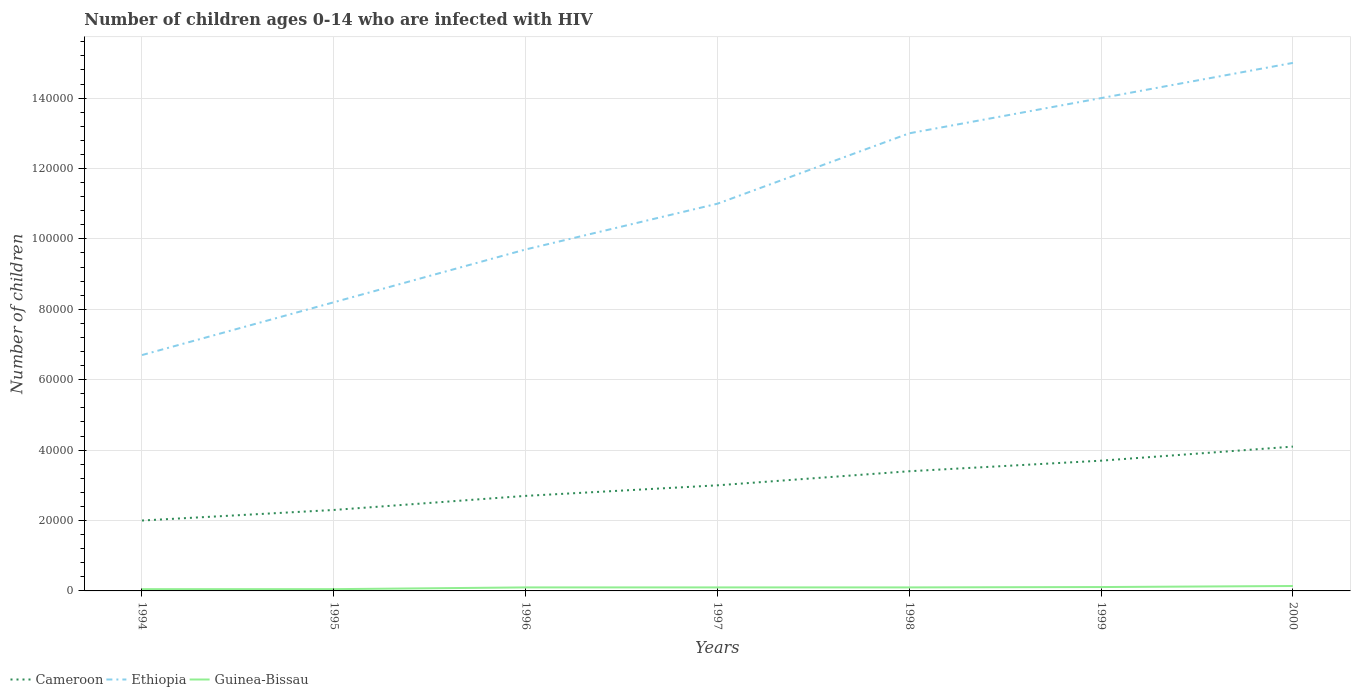Across all years, what is the maximum number of HIV infected children in Ethiopia?
Your response must be concise. 6.70e+04. In which year was the number of HIV infected children in Cameroon maximum?
Offer a very short reply. 1994. What is the total number of HIV infected children in Cameroon in the graph?
Keep it short and to the point. -3000. What is the difference between the highest and the second highest number of HIV infected children in Guinea-Bissau?
Keep it short and to the point. 900. What is the difference between the highest and the lowest number of HIV infected children in Cameroon?
Provide a succinct answer. 3. How many years are there in the graph?
Your answer should be compact. 7. Does the graph contain any zero values?
Your answer should be compact. No. Where does the legend appear in the graph?
Ensure brevity in your answer.  Bottom left. How many legend labels are there?
Your answer should be very brief. 3. What is the title of the graph?
Your answer should be compact. Number of children ages 0-14 who are infected with HIV. What is the label or title of the X-axis?
Keep it short and to the point. Years. What is the label or title of the Y-axis?
Your answer should be compact. Number of children. What is the Number of children in Ethiopia in 1994?
Offer a terse response. 6.70e+04. What is the Number of children in Cameroon in 1995?
Offer a terse response. 2.30e+04. What is the Number of children in Ethiopia in 1995?
Offer a very short reply. 8.20e+04. What is the Number of children of Guinea-Bissau in 1995?
Make the answer very short. 500. What is the Number of children in Cameroon in 1996?
Give a very brief answer. 2.70e+04. What is the Number of children in Ethiopia in 1996?
Ensure brevity in your answer.  9.70e+04. What is the Number of children of Ethiopia in 1997?
Provide a succinct answer. 1.10e+05. What is the Number of children of Guinea-Bissau in 1997?
Your answer should be compact. 1000. What is the Number of children of Cameroon in 1998?
Offer a very short reply. 3.40e+04. What is the Number of children of Cameroon in 1999?
Your answer should be very brief. 3.70e+04. What is the Number of children of Ethiopia in 1999?
Provide a short and direct response. 1.40e+05. What is the Number of children in Guinea-Bissau in 1999?
Offer a terse response. 1100. What is the Number of children of Cameroon in 2000?
Give a very brief answer. 4.10e+04. What is the Number of children of Ethiopia in 2000?
Keep it short and to the point. 1.50e+05. What is the Number of children in Guinea-Bissau in 2000?
Offer a very short reply. 1400. Across all years, what is the maximum Number of children of Cameroon?
Offer a terse response. 4.10e+04. Across all years, what is the maximum Number of children of Ethiopia?
Give a very brief answer. 1.50e+05. Across all years, what is the maximum Number of children in Guinea-Bissau?
Ensure brevity in your answer.  1400. Across all years, what is the minimum Number of children in Ethiopia?
Offer a terse response. 6.70e+04. What is the total Number of children in Cameroon in the graph?
Offer a very short reply. 2.12e+05. What is the total Number of children of Ethiopia in the graph?
Provide a succinct answer. 7.76e+05. What is the total Number of children of Guinea-Bissau in the graph?
Your response must be concise. 6500. What is the difference between the Number of children in Cameroon in 1994 and that in 1995?
Ensure brevity in your answer.  -3000. What is the difference between the Number of children of Ethiopia in 1994 and that in 1995?
Ensure brevity in your answer.  -1.50e+04. What is the difference between the Number of children in Guinea-Bissau in 1994 and that in 1995?
Ensure brevity in your answer.  0. What is the difference between the Number of children of Cameroon in 1994 and that in 1996?
Provide a short and direct response. -7000. What is the difference between the Number of children in Ethiopia in 1994 and that in 1996?
Keep it short and to the point. -3.00e+04. What is the difference between the Number of children in Guinea-Bissau in 1994 and that in 1996?
Keep it short and to the point. -500. What is the difference between the Number of children in Cameroon in 1994 and that in 1997?
Give a very brief answer. -10000. What is the difference between the Number of children of Ethiopia in 1994 and that in 1997?
Ensure brevity in your answer.  -4.30e+04. What is the difference between the Number of children in Guinea-Bissau in 1994 and that in 1997?
Ensure brevity in your answer.  -500. What is the difference between the Number of children in Cameroon in 1994 and that in 1998?
Keep it short and to the point. -1.40e+04. What is the difference between the Number of children of Ethiopia in 1994 and that in 1998?
Offer a terse response. -6.30e+04. What is the difference between the Number of children in Guinea-Bissau in 1994 and that in 1998?
Provide a short and direct response. -500. What is the difference between the Number of children in Cameroon in 1994 and that in 1999?
Give a very brief answer. -1.70e+04. What is the difference between the Number of children of Ethiopia in 1994 and that in 1999?
Offer a very short reply. -7.30e+04. What is the difference between the Number of children of Guinea-Bissau in 1994 and that in 1999?
Offer a terse response. -600. What is the difference between the Number of children in Cameroon in 1994 and that in 2000?
Provide a short and direct response. -2.10e+04. What is the difference between the Number of children in Ethiopia in 1994 and that in 2000?
Offer a very short reply. -8.30e+04. What is the difference between the Number of children in Guinea-Bissau in 1994 and that in 2000?
Offer a terse response. -900. What is the difference between the Number of children in Cameroon in 1995 and that in 1996?
Provide a short and direct response. -4000. What is the difference between the Number of children in Ethiopia in 1995 and that in 1996?
Give a very brief answer. -1.50e+04. What is the difference between the Number of children of Guinea-Bissau in 1995 and that in 1996?
Offer a terse response. -500. What is the difference between the Number of children of Cameroon in 1995 and that in 1997?
Provide a succinct answer. -7000. What is the difference between the Number of children in Ethiopia in 1995 and that in 1997?
Offer a very short reply. -2.80e+04. What is the difference between the Number of children in Guinea-Bissau in 1995 and that in 1997?
Offer a very short reply. -500. What is the difference between the Number of children in Cameroon in 1995 and that in 1998?
Offer a terse response. -1.10e+04. What is the difference between the Number of children of Ethiopia in 1995 and that in 1998?
Keep it short and to the point. -4.80e+04. What is the difference between the Number of children of Guinea-Bissau in 1995 and that in 1998?
Offer a terse response. -500. What is the difference between the Number of children of Cameroon in 1995 and that in 1999?
Provide a succinct answer. -1.40e+04. What is the difference between the Number of children in Ethiopia in 1995 and that in 1999?
Ensure brevity in your answer.  -5.80e+04. What is the difference between the Number of children of Guinea-Bissau in 1995 and that in 1999?
Keep it short and to the point. -600. What is the difference between the Number of children of Cameroon in 1995 and that in 2000?
Offer a terse response. -1.80e+04. What is the difference between the Number of children of Ethiopia in 1995 and that in 2000?
Keep it short and to the point. -6.80e+04. What is the difference between the Number of children in Guinea-Bissau in 1995 and that in 2000?
Offer a terse response. -900. What is the difference between the Number of children in Cameroon in 1996 and that in 1997?
Offer a very short reply. -3000. What is the difference between the Number of children in Ethiopia in 1996 and that in 1997?
Keep it short and to the point. -1.30e+04. What is the difference between the Number of children in Guinea-Bissau in 1996 and that in 1997?
Give a very brief answer. 0. What is the difference between the Number of children of Cameroon in 1996 and that in 1998?
Ensure brevity in your answer.  -7000. What is the difference between the Number of children in Ethiopia in 1996 and that in 1998?
Your answer should be very brief. -3.30e+04. What is the difference between the Number of children in Guinea-Bissau in 1996 and that in 1998?
Offer a very short reply. 0. What is the difference between the Number of children in Cameroon in 1996 and that in 1999?
Provide a succinct answer. -10000. What is the difference between the Number of children of Ethiopia in 1996 and that in 1999?
Your answer should be very brief. -4.30e+04. What is the difference between the Number of children of Guinea-Bissau in 1996 and that in 1999?
Provide a succinct answer. -100. What is the difference between the Number of children of Cameroon in 1996 and that in 2000?
Provide a short and direct response. -1.40e+04. What is the difference between the Number of children of Ethiopia in 1996 and that in 2000?
Ensure brevity in your answer.  -5.30e+04. What is the difference between the Number of children in Guinea-Bissau in 1996 and that in 2000?
Your response must be concise. -400. What is the difference between the Number of children in Cameroon in 1997 and that in 1998?
Keep it short and to the point. -4000. What is the difference between the Number of children in Ethiopia in 1997 and that in 1998?
Your response must be concise. -2.00e+04. What is the difference between the Number of children in Cameroon in 1997 and that in 1999?
Ensure brevity in your answer.  -7000. What is the difference between the Number of children in Ethiopia in 1997 and that in 1999?
Your answer should be compact. -3.00e+04. What is the difference between the Number of children in Guinea-Bissau in 1997 and that in 1999?
Provide a succinct answer. -100. What is the difference between the Number of children in Cameroon in 1997 and that in 2000?
Make the answer very short. -1.10e+04. What is the difference between the Number of children of Guinea-Bissau in 1997 and that in 2000?
Offer a terse response. -400. What is the difference between the Number of children in Cameroon in 1998 and that in 1999?
Make the answer very short. -3000. What is the difference between the Number of children of Ethiopia in 1998 and that in 1999?
Your answer should be very brief. -10000. What is the difference between the Number of children of Guinea-Bissau in 1998 and that in 1999?
Your answer should be very brief. -100. What is the difference between the Number of children in Cameroon in 1998 and that in 2000?
Offer a very short reply. -7000. What is the difference between the Number of children in Ethiopia in 1998 and that in 2000?
Keep it short and to the point. -2.00e+04. What is the difference between the Number of children in Guinea-Bissau in 1998 and that in 2000?
Your response must be concise. -400. What is the difference between the Number of children of Cameroon in 1999 and that in 2000?
Your answer should be compact. -4000. What is the difference between the Number of children in Ethiopia in 1999 and that in 2000?
Offer a terse response. -10000. What is the difference between the Number of children in Guinea-Bissau in 1999 and that in 2000?
Your answer should be compact. -300. What is the difference between the Number of children in Cameroon in 1994 and the Number of children in Ethiopia in 1995?
Give a very brief answer. -6.20e+04. What is the difference between the Number of children in Cameroon in 1994 and the Number of children in Guinea-Bissau in 1995?
Give a very brief answer. 1.95e+04. What is the difference between the Number of children of Ethiopia in 1994 and the Number of children of Guinea-Bissau in 1995?
Your response must be concise. 6.65e+04. What is the difference between the Number of children in Cameroon in 1994 and the Number of children in Ethiopia in 1996?
Make the answer very short. -7.70e+04. What is the difference between the Number of children of Cameroon in 1994 and the Number of children of Guinea-Bissau in 1996?
Your answer should be very brief. 1.90e+04. What is the difference between the Number of children in Ethiopia in 1994 and the Number of children in Guinea-Bissau in 1996?
Your answer should be very brief. 6.60e+04. What is the difference between the Number of children of Cameroon in 1994 and the Number of children of Ethiopia in 1997?
Provide a short and direct response. -9.00e+04. What is the difference between the Number of children in Cameroon in 1994 and the Number of children in Guinea-Bissau in 1997?
Offer a very short reply. 1.90e+04. What is the difference between the Number of children of Ethiopia in 1994 and the Number of children of Guinea-Bissau in 1997?
Give a very brief answer. 6.60e+04. What is the difference between the Number of children of Cameroon in 1994 and the Number of children of Guinea-Bissau in 1998?
Your answer should be compact. 1.90e+04. What is the difference between the Number of children in Ethiopia in 1994 and the Number of children in Guinea-Bissau in 1998?
Your answer should be very brief. 6.60e+04. What is the difference between the Number of children of Cameroon in 1994 and the Number of children of Guinea-Bissau in 1999?
Your answer should be compact. 1.89e+04. What is the difference between the Number of children in Ethiopia in 1994 and the Number of children in Guinea-Bissau in 1999?
Give a very brief answer. 6.59e+04. What is the difference between the Number of children of Cameroon in 1994 and the Number of children of Guinea-Bissau in 2000?
Ensure brevity in your answer.  1.86e+04. What is the difference between the Number of children of Ethiopia in 1994 and the Number of children of Guinea-Bissau in 2000?
Provide a succinct answer. 6.56e+04. What is the difference between the Number of children in Cameroon in 1995 and the Number of children in Ethiopia in 1996?
Offer a very short reply. -7.40e+04. What is the difference between the Number of children of Cameroon in 1995 and the Number of children of Guinea-Bissau in 1996?
Offer a terse response. 2.20e+04. What is the difference between the Number of children of Ethiopia in 1995 and the Number of children of Guinea-Bissau in 1996?
Keep it short and to the point. 8.10e+04. What is the difference between the Number of children in Cameroon in 1995 and the Number of children in Ethiopia in 1997?
Ensure brevity in your answer.  -8.70e+04. What is the difference between the Number of children in Cameroon in 1995 and the Number of children in Guinea-Bissau in 1997?
Provide a succinct answer. 2.20e+04. What is the difference between the Number of children of Ethiopia in 1995 and the Number of children of Guinea-Bissau in 1997?
Give a very brief answer. 8.10e+04. What is the difference between the Number of children of Cameroon in 1995 and the Number of children of Ethiopia in 1998?
Keep it short and to the point. -1.07e+05. What is the difference between the Number of children of Cameroon in 1995 and the Number of children of Guinea-Bissau in 1998?
Provide a short and direct response. 2.20e+04. What is the difference between the Number of children in Ethiopia in 1995 and the Number of children in Guinea-Bissau in 1998?
Ensure brevity in your answer.  8.10e+04. What is the difference between the Number of children of Cameroon in 1995 and the Number of children of Ethiopia in 1999?
Your response must be concise. -1.17e+05. What is the difference between the Number of children in Cameroon in 1995 and the Number of children in Guinea-Bissau in 1999?
Your answer should be very brief. 2.19e+04. What is the difference between the Number of children in Ethiopia in 1995 and the Number of children in Guinea-Bissau in 1999?
Keep it short and to the point. 8.09e+04. What is the difference between the Number of children of Cameroon in 1995 and the Number of children of Ethiopia in 2000?
Provide a succinct answer. -1.27e+05. What is the difference between the Number of children of Cameroon in 1995 and the Number of children of Guinea-Bissau in 2000?
Ensure brevity in your answer.  2.16e+04. What is the difference between the Number of children in Ethiopia in 1995 and the Number of children in Guinea-Bissau in 2000?
Offer a terse response. 8.06e+04. What is the difference between the Number of children in Cameroon in 1996 and the Number of children in Ethiopia in 1997?
Provide a short and direct response. -8.30e+04. What is the difference between the Number of children of Cameroon in 1996 and the Number of children of Guinea-Bissau in 1997?
Keep it short and to the point. 2.60e+04. What is the difference between the Number of children of Ethiopia in 1996 and the Number of children of Guinea-Bissau in 1997?
Keep it short and to the point. 9.60e+04. What is the difference between the Number of children in Cameroon in 1996 and the Number of children in Ethiopia in 1998?
Your answer should be very brief. -1.03e+05. What is the difference between the Number of children of Cameroon in 1996 and the Number of children of Guinea-Bissau in 1998?
Offer a terse response. 2.60e+04. What is the difference between the Number of children of Ethiopia in 1996 and the Number of children of Guinea-Bissau in 1998?
Keep it short and to the point. 9.60e+04. What is the difference between the Number of children in Cameroon in 1996 and the Number of children in Ethiopia in 1999?
Offer a terse response. -1.13e+05. What is the difference between the Number of children of Cameroon in 1996 and the Number of children of Guinea-Bissau in 1999?
Give a very brief answer. 2.59e+04. What is the difference between the Number of children of Ethiopia in 1996 and the Number of children of Guinea-Bissau in 1999?
Your answer should be compact. 9.59e+04. What is the difference between the Number of children in Cameroon in 1996 and the Number of children in Ethiopia in 2000?
Make the answer very short. -1.23e+05. What is the difference between the Number of children in Cameroon in 1996 and the Number of children in Guinea-Bissau in 2000?
Provide a short and direct response. 2.56e+04. What is the difference between the Number of children in Ethiopia in 1996 and the Number of children in Guinea-Bissau in 2000?
Make the answer very short. 9.56e+04. What is the difference between the Number of children of Cameroon in 1997 and the Number of children of Ethiopia in 1998?
Keep it short and to the point. -1.00e+05. What is the difference between the Number of children of Cameroon in 1997 and the Number of children of Guinea-Bissau in 1998?
Provide a short and direct response. 2.90e+04. What is the difference between the Number of children in Ethiopia in 1997 and the Number of children in Guinea-Bissau in 1998?
Give a very brief answer. 1.09e+05. What is the difference between the Number of children of Cameroon in 1997 and the Number of children of Ethiopia in 1999?
Your response must be concise. -1.10e+05. What is the difference between the Number of children of Cameroon in 1997 and the Number of children of Guinea-Bissau in 1999?
Keep it short and to the point. 2.89e+04. What is the difference between the Number of children of Ethiopia in 1997 and the Number of children of Guinea-Bissau in 1999?
Make the answer very short. 1.09e+05. What is the difference between the Number of children in Cameroon in 1997 and the Number of children in Guinea-Bissau in 2000?
Provide a succinct answer. 2.86e+04. What is the difference between the Number of children of Ethiopia in 1997 and the Number of children of Guinea-Bissau in 2000?
Your response must be concise. 1.09e+05. What is the difference between the Number of children of Cameroon in 1998 and the Number of children of Ethiopia in 1999?
Your answer should be very brief. -1.06e+05. What is the difference between the Number of children of Cameroon in 1998 and the Number of children of Guinea-Bissau in 1999?
Your answer should be very brief. 3.29e+04. What is the difference between the Number of children of Ethiopia in 1998 and the Number of children of Guinea-Bissau in 1999?
Provide a succinct answer. 1.29e+05. What is the difference between the Number of children in Cameroon in 1998 and the Number of children in Ethiopia in 2000?
Your response must be concise. -1.16e+05. What is the difference between the Number of children of Cameroon in 1998 and the Number of children of Guinea-Bissau in 2000?
Ensure brevity in your answer.  3.26e+04. What is the difference between the Number of children in Ethiopia in 1998 and the Number of children in Guinea-Bissau in 2000?
Your answer should be compact. 1.29e+05. What is the difference between the Number of children of Cameroon in 1999 and the Number of children of Ethiopia in 2000?
Offer a very short reply. -1.13e+05. What is the difference between the Number of children of Cameroon in 1999 and the Number of children of Guinea-Bissau in 2000?
Your answer should be compact. 3.56e+04. What is the difference between the Number of children in Ethiopia in 1999 and the Number of children in Guinea-Bissau in 2000?
Your response must be concise. 1.39e+05. What is the average Number of children in Cameroon per year?
Give a very brief answer. 3.03e+04. What is the average Number of children in Ethiopia per year?
Offer a very short reply. 1.11e+05. What is the average Number of children in Guinea-Bissau per year?
Provide a short and direct response. 928.57. In the year 1994, what is the difference between the Number of children of Cameroon and Number of children of Ethiopia?
Offer a terse response. -4.70e+04. In the year 1994, what is the difference between the Number of children of Cameroon and Number of children of Guinea-Bissau?
Make the answer very short. 1.95e+04. In the year 1994, what is the difference between the Number of children in Ethiopia and Number of children in Guinea-Bissau?
Offer a very short reply. 6.65e+04. In the year 1995, what is the difference between the Number of children in Cameroon and Number of children in Ethiopia?
Your answer should be very brief. -5.90e+04. In the year 1995, what is the difference between the Number of children in Cameroon and Number of children in Guinea-Bissau?
Make the answer very short. 2.25e+04. In the year 1995, what is the difference between the Number of children of Ethiopia and Number of children of Guinea-Bissau?
Provide a succinct answer. 8.15e+04. In the year 1996, what is the difference between the Number of children of Cameroon and Number of children of Ethiopia?
Provide a succinct answer. -7.00e+04. In the year 1996, what is the difference between the Number of children of Cameroon and Number of children of Guinea-Bissau?
Provide a short and direct response. 2.60e+04. In the year 1996, what is the difference between the Number of children of Ethiopia and Number of children of Guinea-Bissau?
Ensure brevity in your answer.  9.60e+04. In the year 1997, what is the difference between the Number of children in Cameroon and Number of children in Ethiopia?
Your answer should be very brief. -8.00e+04. In the year 1997, what is the difference between the Number of children in Cameroon and Number of children in Guinea-Bissau?
Provide a short and direct response. 2.90e+04. In the year 1997, what is the difference between the Number of children of Ethiopia and Number of children of Guinea-Bissau?
Your answer should be very brief. 1.09e+05. In the year 1998, what is the difference between the Number of children in Cameroon and Number of children in Ethiopia?
Keep it short and to the point. -9.60e+04. In the year 1998, what is the difference between the Number of children in Cameroon and Number of children in Guinea-Bissau?
Your answer should be compact. 3.30e+04. In the year 1998, what is the difference between the Number of children in Ethiopia and Number of children in Guinea-Bissau?
Give a very brief answer. 1.29e+05. In the year 1999, what is the difference between the Number of children in Cameroon and Number of children in Ethiopia?
Keep it short and to the point. -1.03e+05. In the year 1999, what is the difference between the Number of children in Cameroon and Number of children in Guinea-Bissau?
Your answer should be compact. 3.59e+04. In the year 1999, what is the difference between the Number of children in Ethiopia and Number of children in Guinea-Bissau?
Your response must be concise. 1.39e+05. In the year 2000, what is the difference between the Number of children in Cameroon and Number of children in Ethiopia?
Keep it short and to the point. -1.09e+05. In the year 2000, what is the difference between the Number of children in Cameroon and Number of children in Guinea-Bissau?
Ensure brevity in your answer.  3.96e+04. In the year 2000, what is the difference between the Number of children in Ethiopia and Number of children in Guinea-Bissau?
Your answer should be very brief. 1.49e+05. What is the ratio of the Number of children of Cameroon in 1994 to that in 1995?
Keep it short and to the point. 0.87. What is the ratio of the Number of children in Ethiopia in 1994 to that in 1995?
Your answer should be compact. 0.82. What is the ratio of the Number of children in Cameroon in 1994 to that in 1996?
Ensure brevity in your answer.  0.74. What is the ratio of the Number of children of Ethiopia in 1994 to that in 1996?
Provide a short and direct response. 0.69. What is the ratio of the Number of children in Ethiopia in 1994 to that in 1997?
Your answer should be very brief. 0.61. What is the ratio of the Number of children of Cameroon in 1994 to that in 1998?
Keep it short and to the point. 0.59. What is the ratio of the Number of children of Ethiopia in 1994 to that in 1998?
Provide a succinct answer. 0.52. What is the ratio of the Number of children in Cameroon in 1994 to that in 1999?
Provide a succinct answer. 0.54. What is the ratio of the Number of children in Ethiopia in 1994 to that in 1999?
Your answer should be very brief. 0.48. What is the ratio of the Number of children of Guinea-Bissau in 1994 to that in 1999?
Make the answer very short. 0.45. What is the ratio of the Number of children in Cameroon in 1994 to that in 2000?
Offer a terse response. 0.49. What is the ratio of the Number of children of Ethiopia in 1994 to that in 2000?
Ensure brevity in your answer.  0.45. What is the ratio of the Number of children of Guinea-Bissau in 1994 to that in 2000?
Give a very brief answer. 0.36. What is the ratio of the Number of children of Cameroon in 1995 to that in 1996?
Offer a terse response. 0.85. What is the ratio of the Number of children of Ethiopia in 1995 to that in 1996?
Your answer should be very brief. 0.85. What is the ratio of the Number of children of Guinea-Bissau in 1995 to that in 1996?
Your answer should be compact. 0.5. What is the ratio of the Number of children in Cameroon in 1995 to that in 1997?
Give a very brief answer. 0.77. What is the ratio of the Number of children of Ethiopia in 1995 to that in 1997?
Make the answer very short. 0.75. What is the ratio of the Number of children of Cameroon in 1995 to that in 1998?
Give a very brief answer. 0.68. What is the ratio of the Number of children in Ethiopia in 1995 to that in 1998?
Give a very brief answer. 0.63. What is the ratio of the Number of children in Cameroon in 1995 to that in 1999?
Offer a very short reply. 0.62. What is the ratio of the Number of children of Ethiopia in 1995 to that in 1999?
Provide a short and direct response. 0.59. What is the ratio of the Number of children in Guinea-Bissau in 1995 to that in 1999?
Provide a short and direct response. 0.45. What is the ratio of the Number of children in Cameroon in 1995 to that in 2000?
Keep it short and to the point. 0.56. What is the ratio of the Number of children in Ethiopia in 1995 to that in 2000?
Make the answer very short. 0.55. What is the ratio of the Number of children of Guinea-Bissau in 1995 to that in 2000?
Provide a short and direct response. 0.36. What is the ratio of the Number of children in Cameroon in 1996 to that in 1997?
Make the answer very short. 0.9. What is the ratio of the Number of children in Ethiopia in 1996 to that in 1997?
Make the answer very short. 0.88. What is the ratio of the Number of children of Cameroon in 1996 to that in 1998?
Your response must be concise. 0.79. What is the ratio of the Number of children of Ethiopia in 1996 to that in 1998?
Keep it short and to the point. 0.75. What is the ratio of the Number of children of Guinea-Bissau in 1996 to that in 1998?
Offer a very short reply. 1. What is the ratio of the Number of children in Cameroon in 1996 to that in 1999?
Offer a terse response. 0.73. What is the ratio of the Number of children of Ethiopia in 1996 to that in 1999?
Provide a succinct answer. 0.69. What is the ratio of the Number of children in Cameroon in 1996 to that in 2000?
Offer a terse response. 0.66. What is the ratio of the Number of children of Ethiopia in 1996 to that in 2000?
Make the answer very short. 0.65. What is the ratio of the Number of children in Cameroon in 1997 to that in 1998?
Ensure brevity in your answer.  0.88. What is the ratio of the Number of children of Ethiopia in 1997 to that in 1998?
Your response must be concise. 0.85. What is the ratio of the Number of children in Guinea-Bissau in 1997 to that in 1998?
Offer a very short reply. 1. What is the ratio of the Number of children of Cameroon in 1997 to that in 1999?
Your answer should be very brief. 0.81. What is the ratio of the Number of children of Ethiopia in 1997 to that in 1999?
Provide a succinct answer. 0.79. What is the ratio of the Number of children of Guinea-Bissau in 1997 to that in 1999?
Offer a very short reply. 0.91. What is the ratio of the Number of children of Cameroon in 1997 to that in 2000?
Your response must be concise. 0.73. What is the ratio of the Number of children of Ethiopia in 1997 to that in 2000?
Your answer should be compact. 0.73. What is the ratio of the Number of children of Cameroon in 1998 to that in 1999?
Offer a terse response. 0.92. What is the ratio of the Number of children in Ethiopia in 1998 to that in 1999?
Offer a terse response. 0.93. What is the ratio of the Number of children of Guinea-Bissau in 1998 to that in 1999?
Provide a succinct answer. 0.91. What is the ratio of the Number of children of Cameroon in 1998 to that in 2000?
Keep it short and to the point. 0.83. What is the ratio of the Number of children in Ethiopia in 1998 to that in 2000?
Offer a terse response. 0.87. What is the ratio of the Number of children of Cameroon in 1999 to that in 2000?
Make the answer very short. 0.9. What is the ratio of the Number of children of Guinea-Bissau in 1999 to that in 2000?
Make the answer very short. 0.79. What is the difference between the highest and the second highest Number of children of Cameroon?
Provide a succinct answer. 4000. What is the difference between the highest and the second highest Number of children in Ethiopia?
Your answer should be very brief. 10000. What is the difference between the highest and the second highest Number of children of Guinea-Bissau?
Your answer should be compact. 300. What is the difference between the highest and the lowest Number of children in Cameroon?
Make the answer very short. 2.10e+04. What is the difference between the highest and the lowest Number of children of Ethiopia?
Your answer should be compact. 8.30e+04. What is the difference between the highest and the lowest Number of children in Guinea-Bissau?
Provide a succinct answer. 900. 